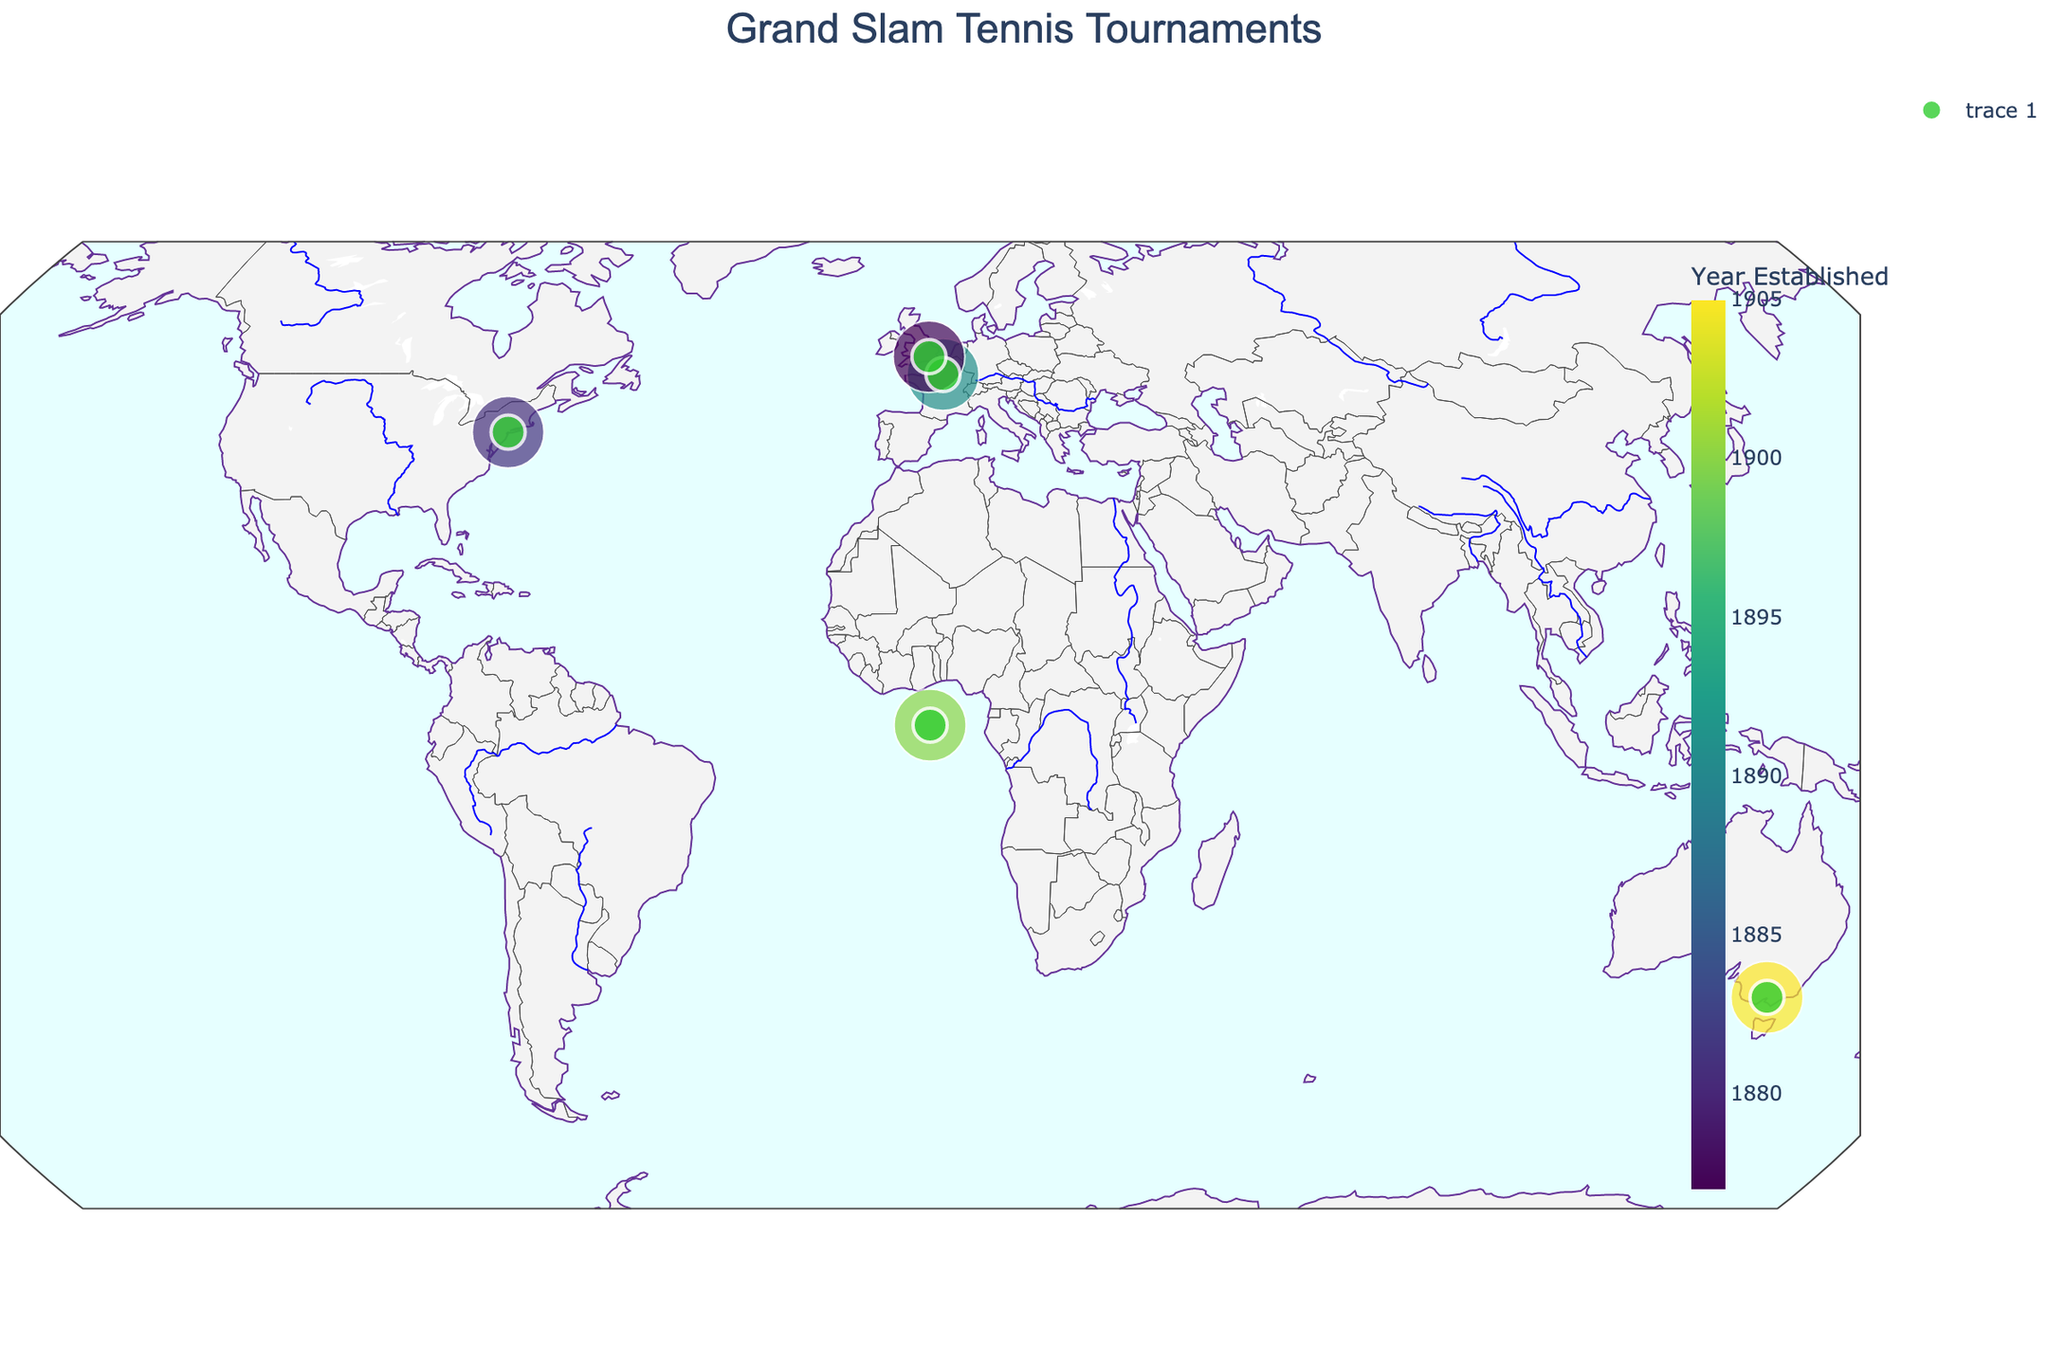What's the title of the map? The title is usually placed at the top of the map and is given in the `title` parameter in the code.
Answer: Grand Slam Tennis Tournaments How many cities are shown on the map? Each point on the map represents a city. By counting the points (Melbourne, Paris, London, New York City, and various for Davis Cup), we get the number of cities.
Answer: 5 Which Grand Slam tournament is the oldest? The color scale and the hover data include the Year Established. By checking, Wimbledon is the oldest established in 1877.
Answer: Wimbledon What is the location (latitude and longitude) of the US Open? Hovering over the US Open point reveals detailed data. The US Open is in New York City with coordinates 40.7128 latitude and -74.0060 longitude.
Answer: 40.7128, -74.0060 Which tournament is represented by a green marker in the United Kingdom? By identifying the green marker in the United Kingdom, which when hovered over, shows it represents Wimbledon.
Answer: Wimbledon What's the difference in years of establishment between the oldest and the newest Grand Slam? The oldest is Wimbledon (1877) and the newest is the Australian Open (1905). The difference is 1905 - 1877.
Answer: 28 years Which tournament is known for its extreme heat? By checking the historical significance in the hover data, the Australian Open in Melbourne is known for extreme heat.
Answer: Australian Open Which Grand Slam is held on a clay court? The hover data shows the historical significance, identifying the French Open in Paris as held on a clay court.
Answer: French Open Which tournament location is the farthest south? By comparing the latitude, Melbourne (Australian Open) at -37.8136 is the farthest south.
Answer: Australian Open How many Grand Slam tournaments were established before 1900? Checking the Year Established values, Wimbledon (1877), French Open (1891), and US Open (1881) are before 1900.
Answer: 3 